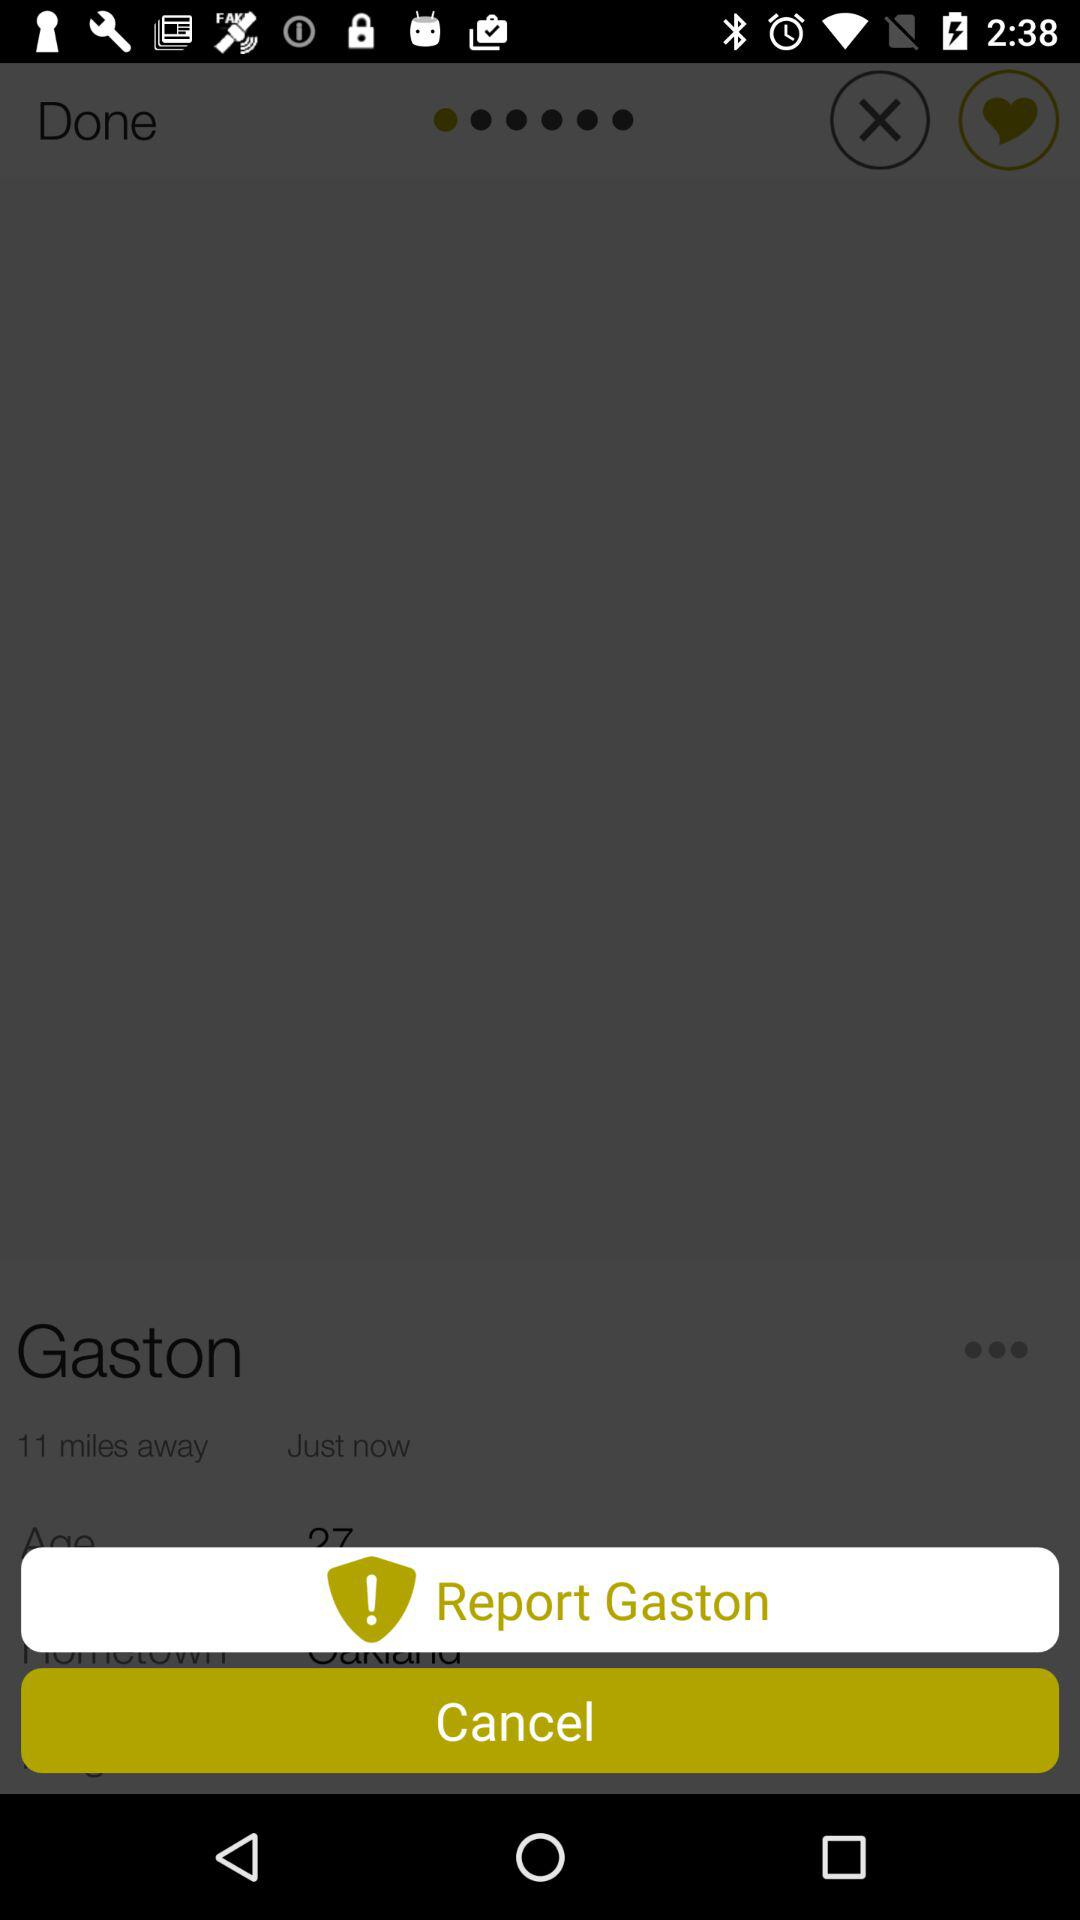What is the age of Gaston?
When the provided information is insufficient, respond with <no answer>. <no answer> 